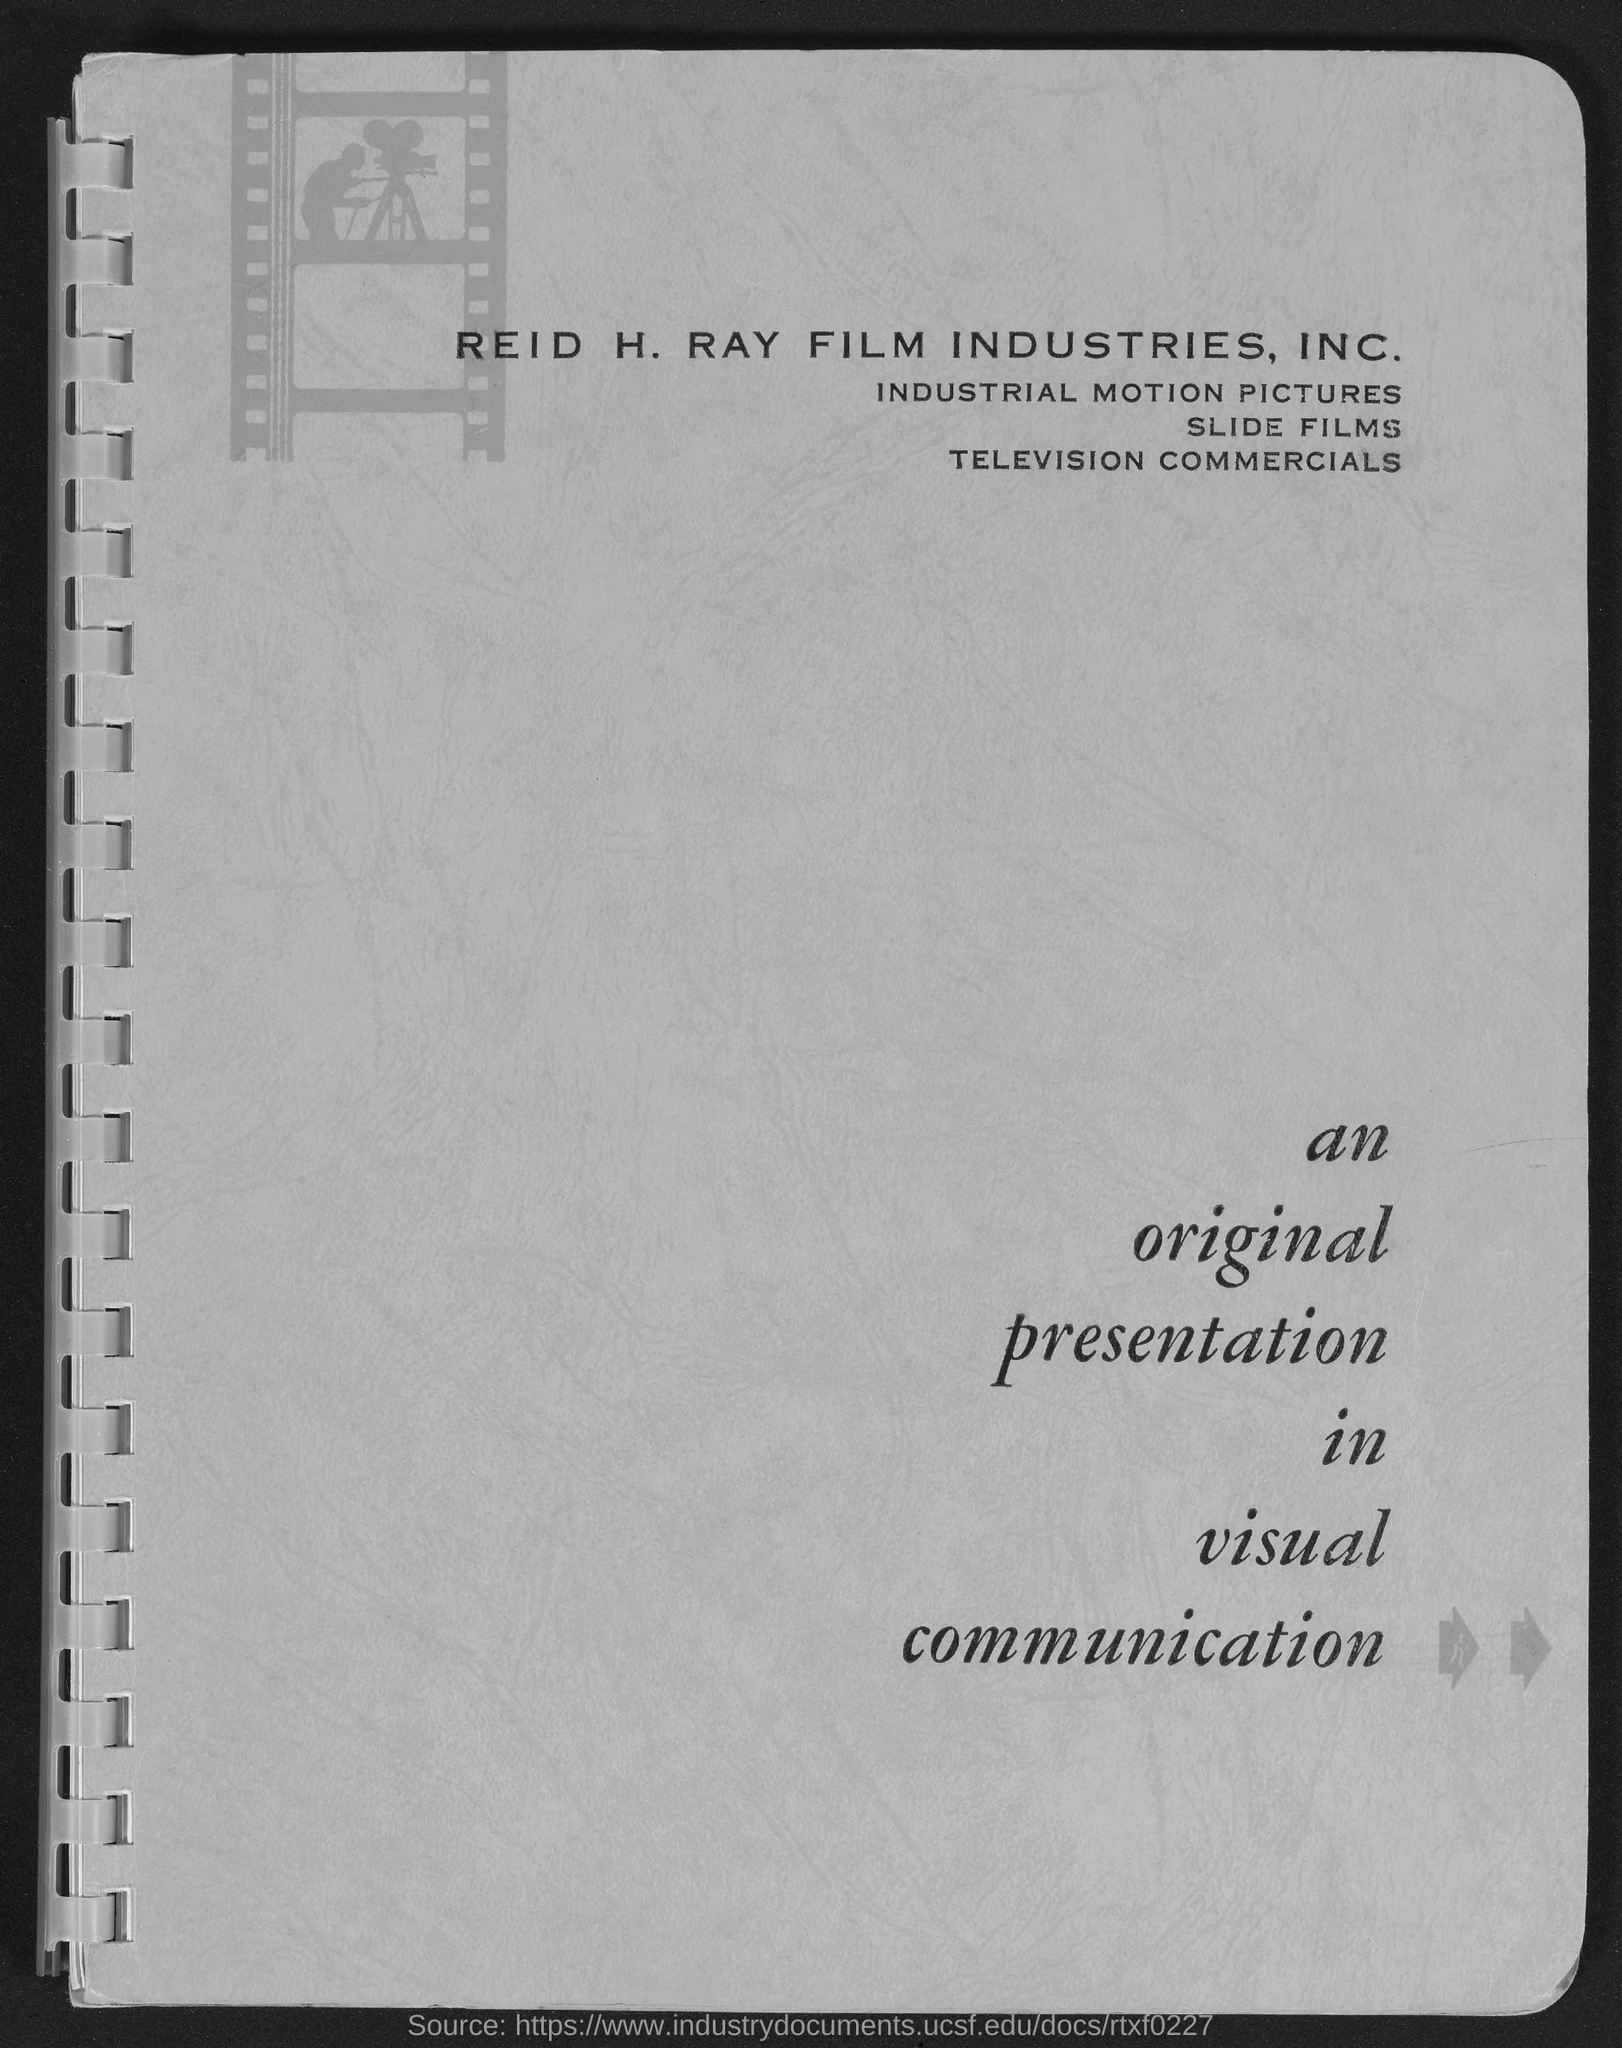Mention a couple of crucial points in this snapshot. This page bears the title 'An original presentation in visual communication.' 